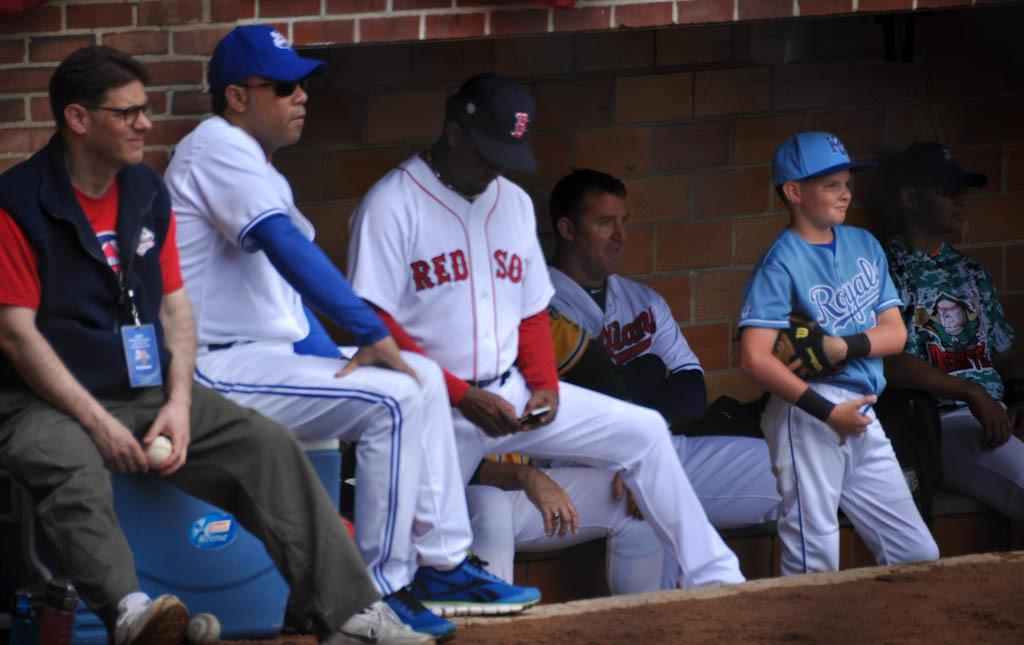<image>
Write a terse but informative summary of the picture. a Red Sox player is looking at his cell phone 